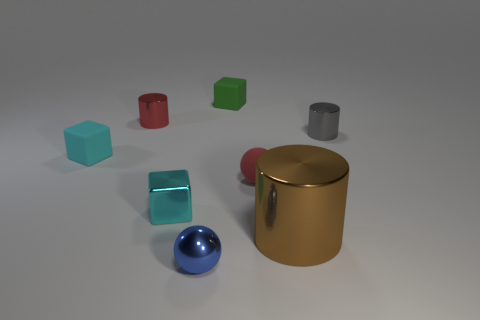Add 1 green matte cubes. How many objects exist? 9 Subtract all tiny red metallic cylinders. How many cylinders are left? 2 Subtract 3 cylinders. How many cylinders are left? 0 Subtract all blue balls. How many brown cylinders are left? 1 Add 6 small red cylinders. How many small red cylinders are left? 7 Add 5 small blue shiny balls. How many small blue shiny balls exist? 6 Subtract all green blocks. How many blocks are left? 2 Subtract 0 red cubes. How many objects are left? 8 Subtract all spheres. How many objects are left? 6 Subtract all cyan blocks. Subtract all blue balls. How many blocks are left? 1 